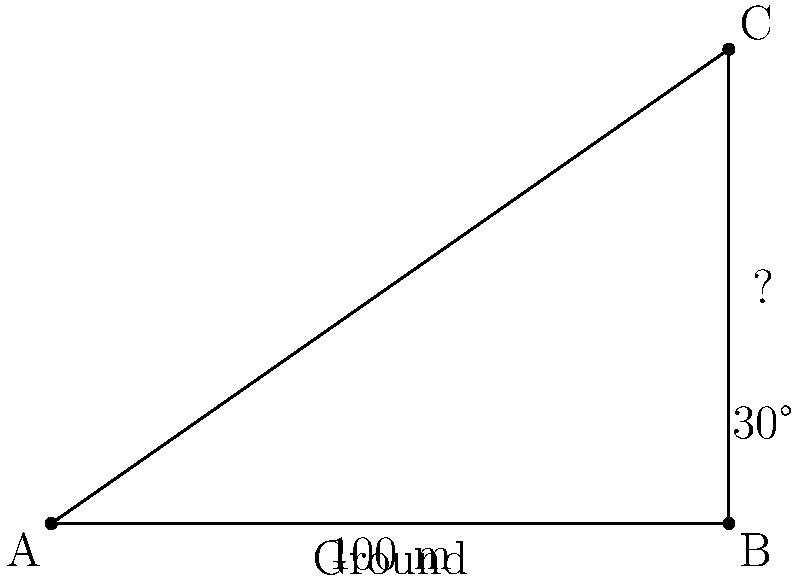You're tasked with determining the height of your rival political party's headquarters. Standing 100 meters away from the base of the building, you measure the angle of elevation to the top of the building to be 30°. Using trigonometric ratios, calculate the height of the building to the nearest meter. Let's approach this step-by-step:

1) We can model this situation as a right-angled triangle, where:
   - The base of the triangle is the distance from you to the building (100 m)
   - The height of the triangle is the height of the building (what we're solving for)
   - The angle between the ground and your line of sight is 30°

2) In this right-angled triangle, we know:
   - The adjacent side (100 m)
   - The angle (30°)
   - We need to find the opposite side (height)

3) The trigonometric ratio that relates the opposite side to the adjacent side is tangent:

   $\tan \theta = \frac{\text{opposite}}{\text{adjacent}}$

4) Substituting our known values:

   $\tan 30° = \frac{\text{height}}{100}$

5) Rearranging to solve for height:

   $\text{height} = 100 \times \tan 30°$

6) Calculate:
   $\text{height} = 100 \times 0.5773... \approx 57.73$ meters

7) Rounding to the nearest meter:

   $\text{height} \approx 58$ meters
Answer: 58 meters 